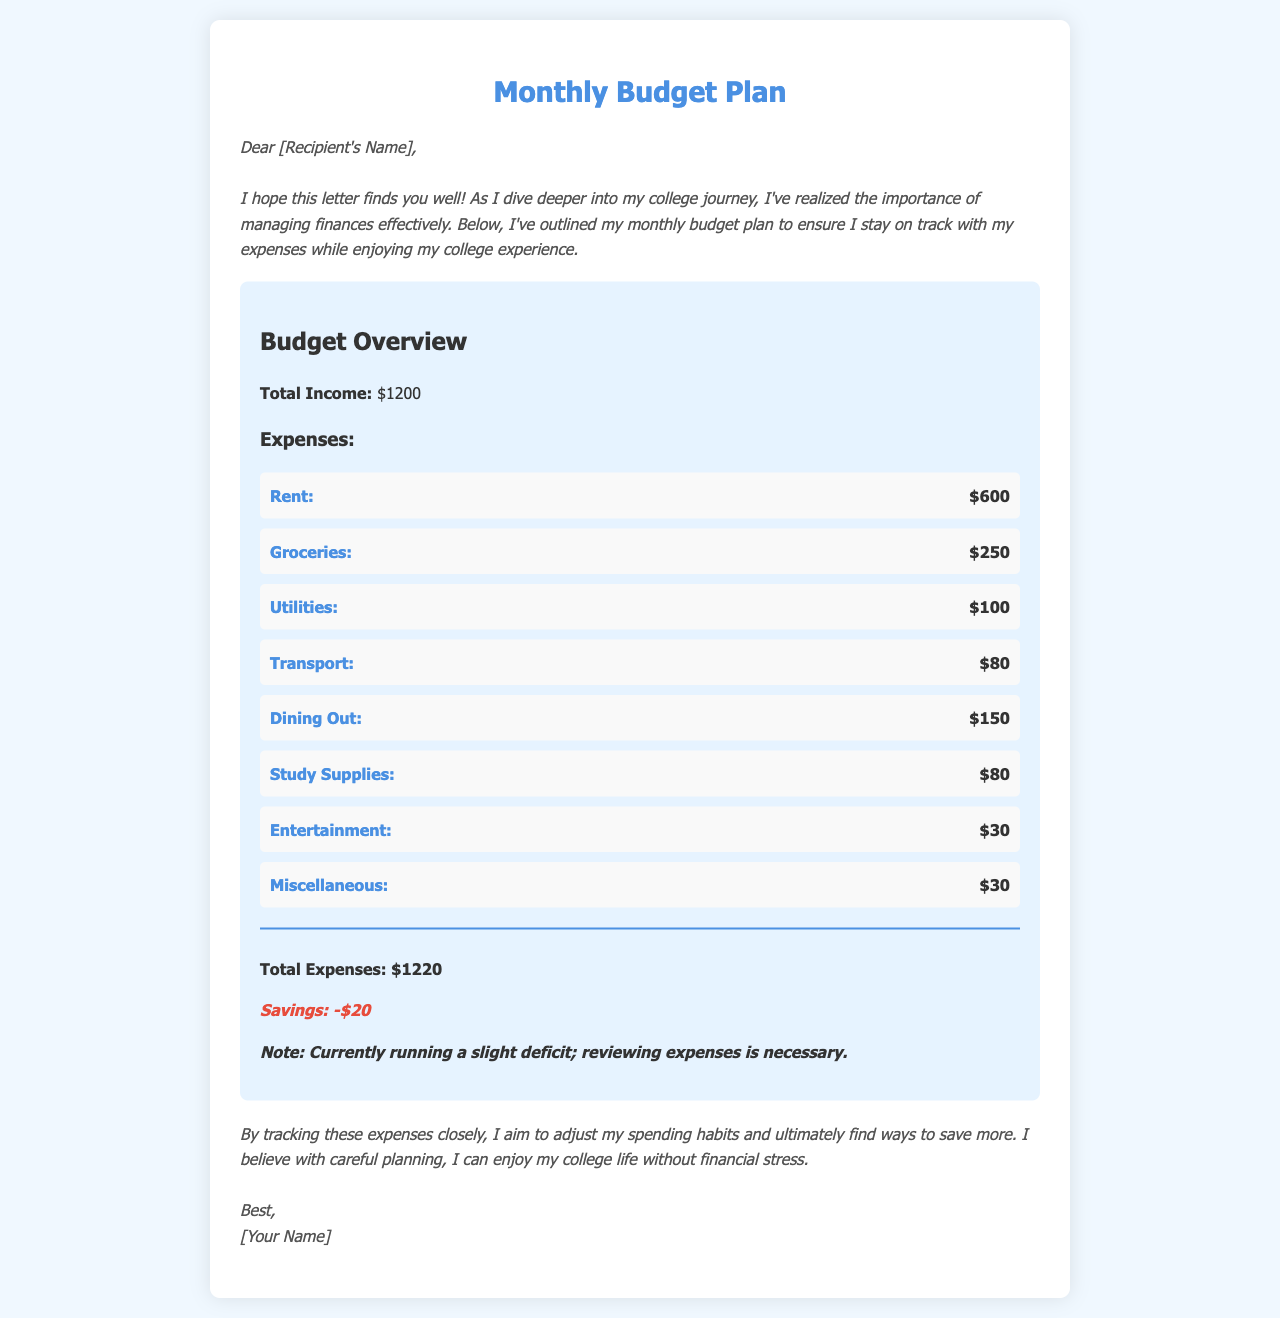What is the total income? The total income is specified in the budget overview section of the document, which is $1200.
Answer: $1200 How much is allocated for rent? The rent expense is listed under the expenses section of the document, which is $600.
Answer: $600 What is the amount for groceries? The groceries expense is detailed in the expense list, amounting to $250.
Answer: $250 What is the total of the expenses? The total expenses, as stated at the end of the expense list, is $1220.
Answer: $1220 How much deficit does the budget plan show? The document notes a savings of -$20, indicating a deficit of this amount.
Answer: -$20 What category has the highest expense? Rent has the highest expense listed, which is $600.
Answer: Rent Is the individual reviewing their expenses? The letter mentions a need to review expenses due to the deficit, indicating the individual is indeed reviewing them.
Answer: Yes What is the purpose of this letter? The letter aims to outline a monthly budget plan to manage finances effectively during college.
Answer: Monthly budget plan What is the last item listed under expenses? The last item listed under expenses is "Miscellaneous," with an amount of $30.
Answer: Miscellaneous What style is the letter written in? The letter is written in a conversational and friendly style, aimed at communicating a personal budget effectively.
Answer: Conversational 